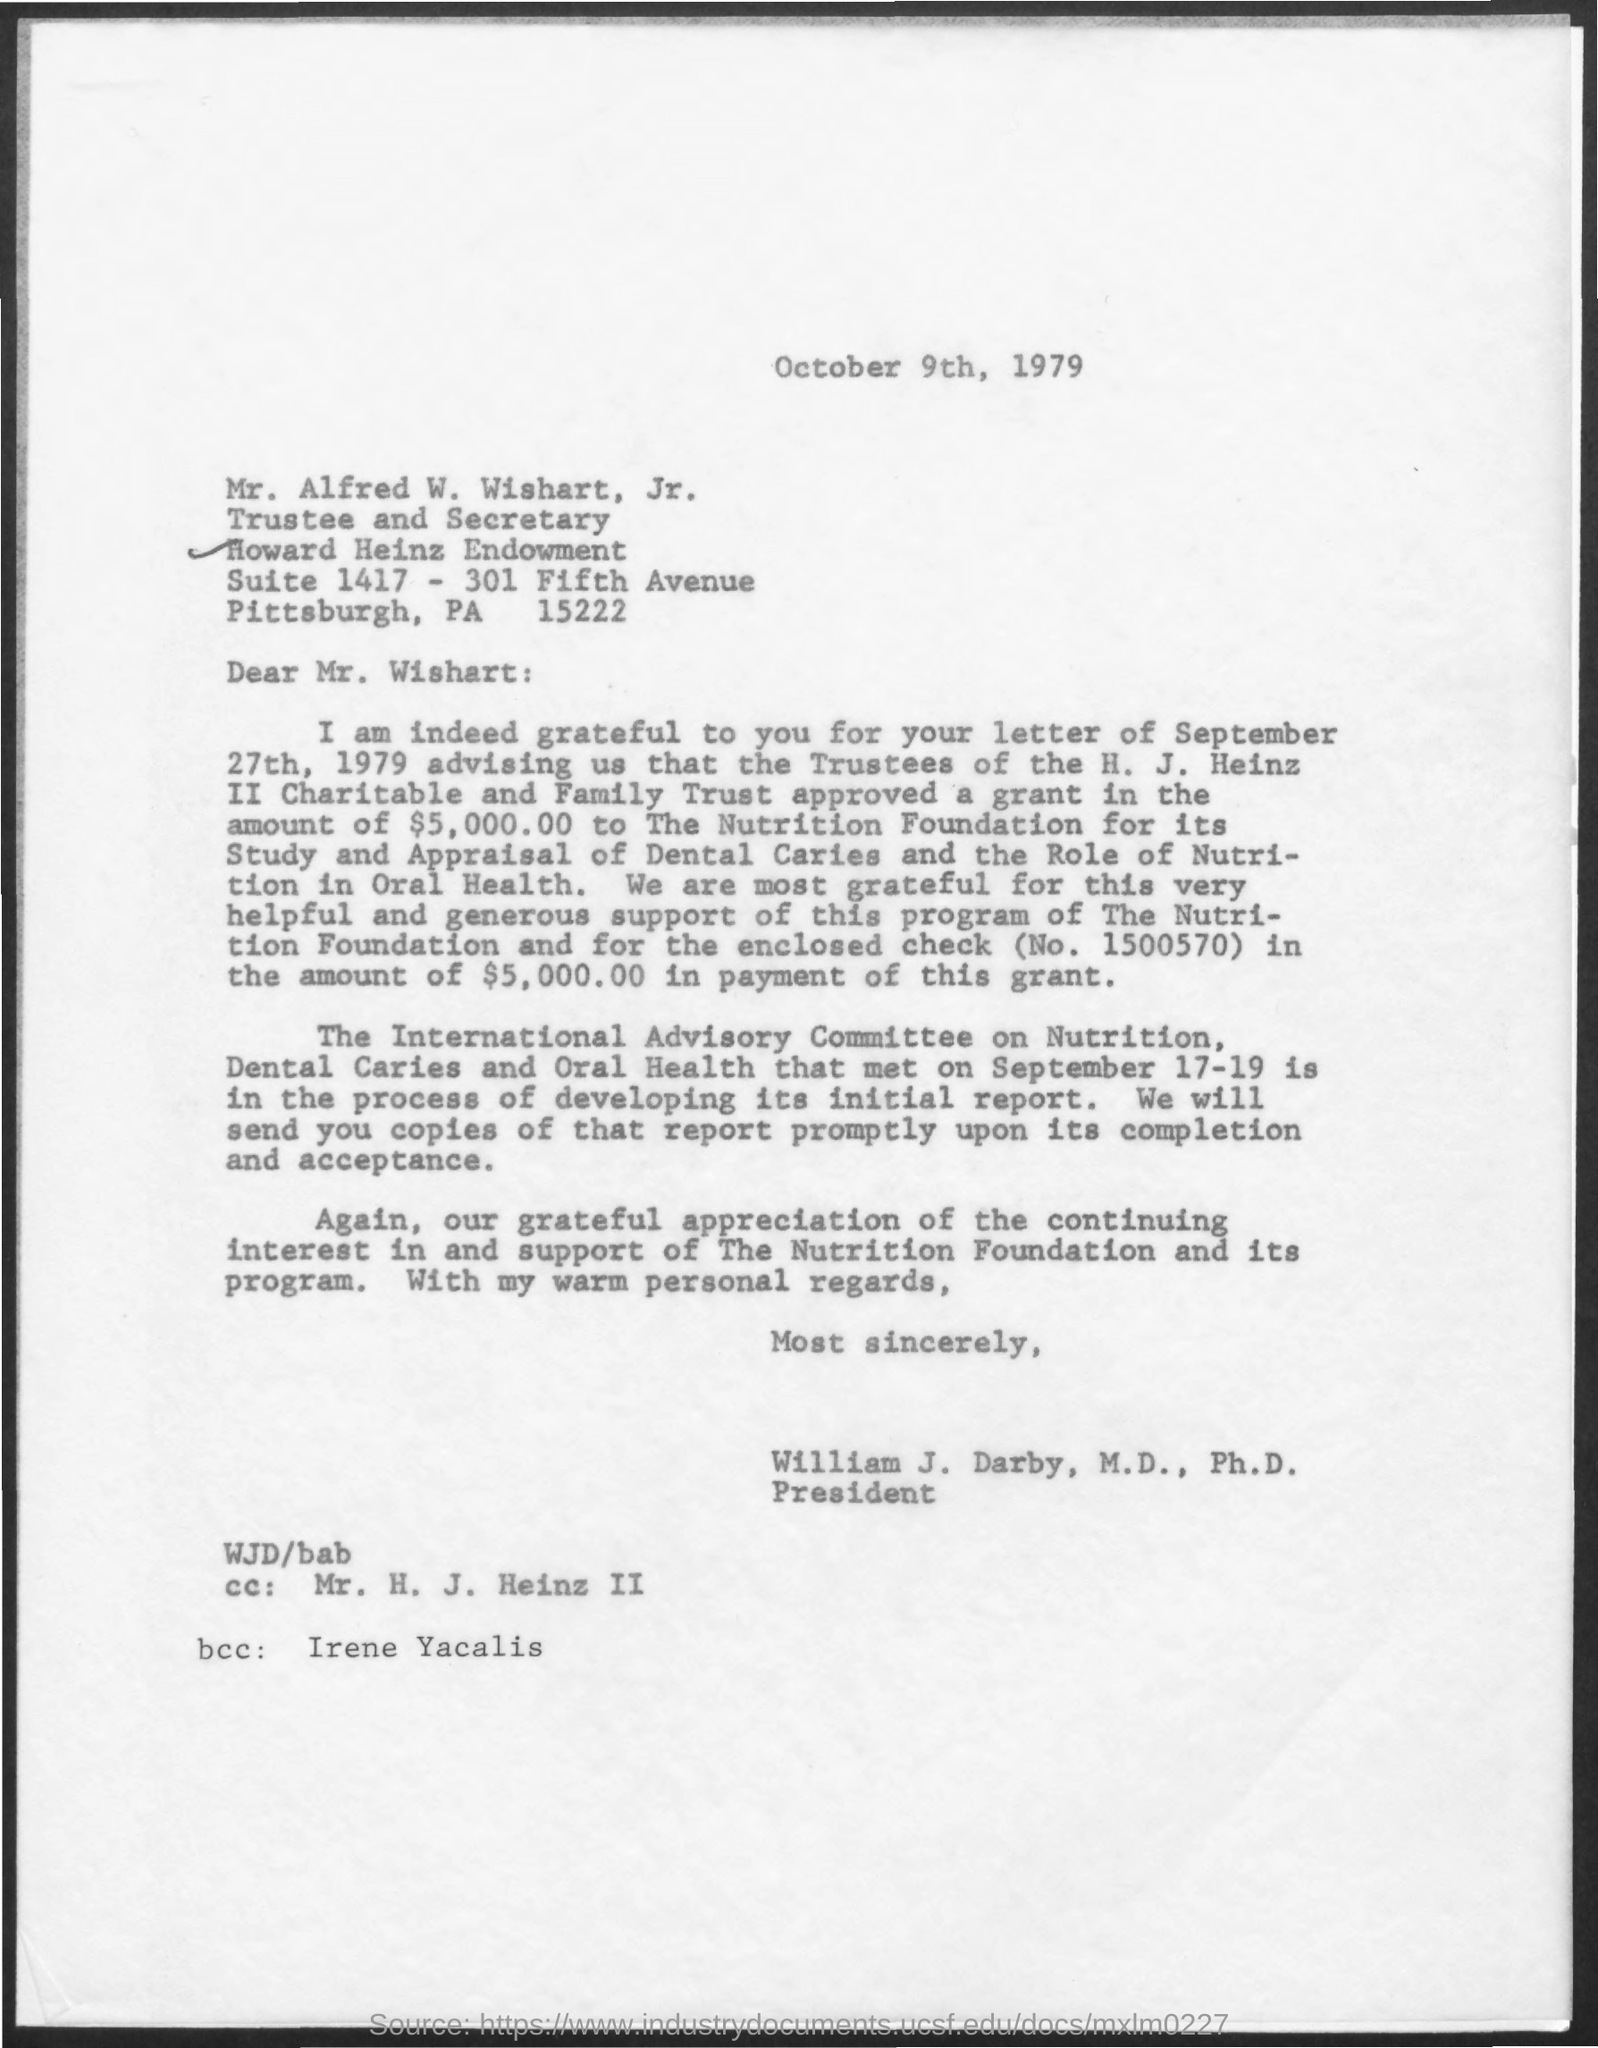Indicate a few pertinent items in this graphic. The recipient of the letter is the BCC, identified as Irene Yacalis. The letter contains the amount of $5,000.00 as written. The individual referred to as "the CC" in the letter is Mr. H. J. Heinz II. The memorandum is dated October 9th, 1979. 